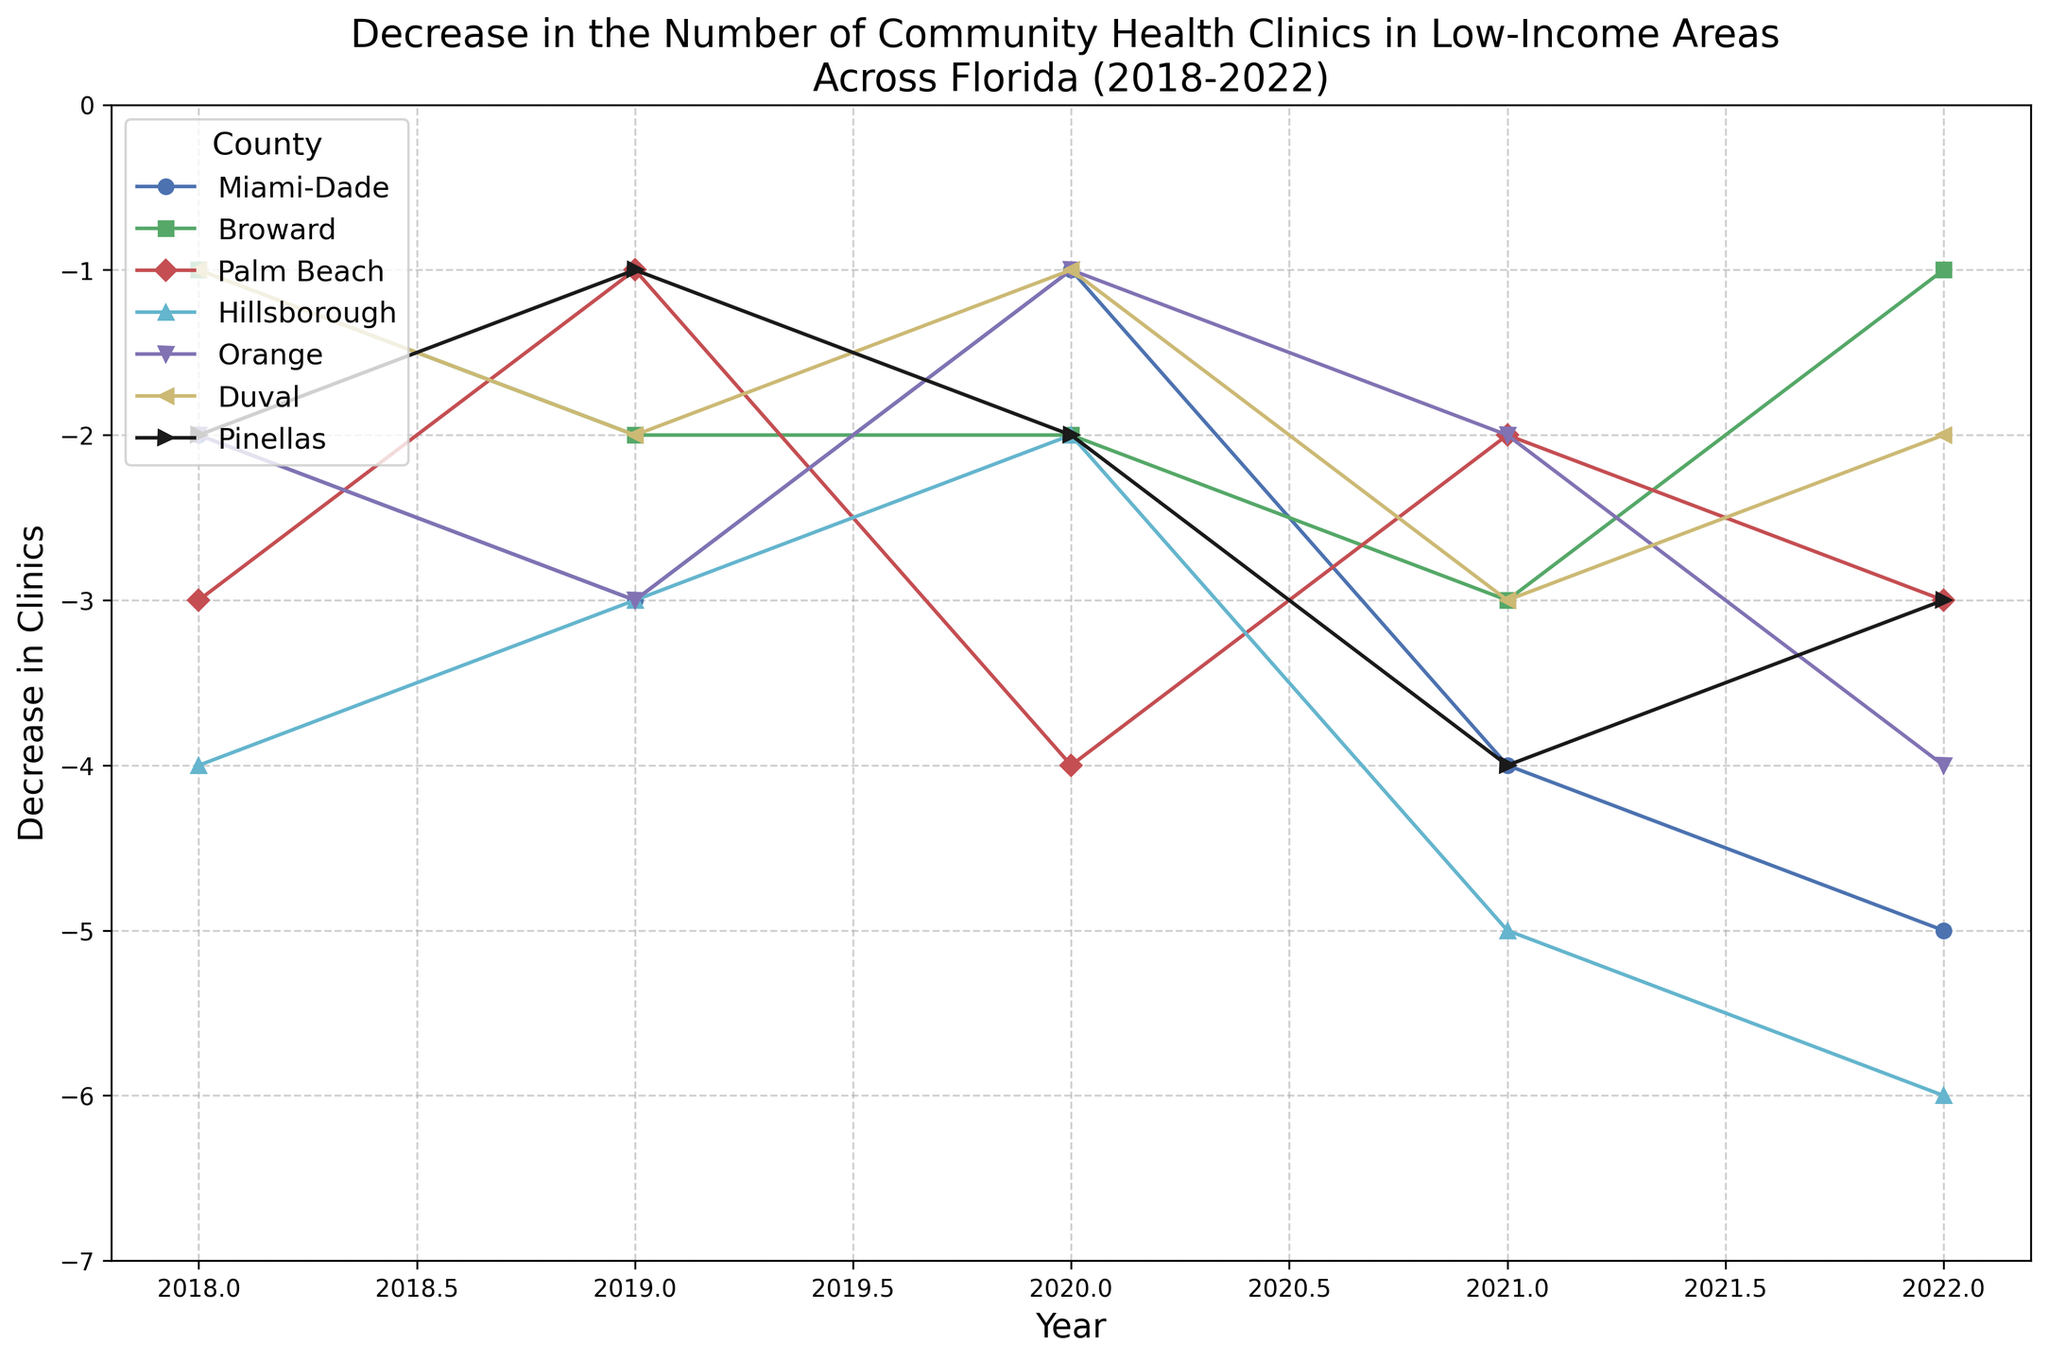What county experienced the most significant reduction in clinics in 2022? To identify the largest decrease in 2022, locate the data points corresponding to that year and note the value. The county with the value farthest from zero has the largest reduction. In 2022, Hillsborough had the most significant reduction with -6 clinics.
Answer: Hillsborough Which county had the smallest reduction in community health clinics over the 5 years? To find the smallest total reduction, sum the decrease in clinics for each county across all years. Compare these sums. Duval had reductions of (-1) + (-2) + (-1) + (-3) + (-2) = -9, which is the smallest.
Answer: Duval In which year did Pinellas county see its highest reduction in community health clinics? Look at the line representing Pinellas county and find the year corresponding to the lowest point on the graph. The highest reduction occurred in 2021 with -4 clinics.
Answer: 2021 Compare the decrease in clinics in 2019 between Miami-Dade and Orange counties. Which had a greater reduction? Compare the points for Miami-Dade and Orange in 2019. Miami-Dade had -3 and Orange had -3. Since the values are the same, there is no greater reduction.
Answer: Equal What is the average yearly decrease in community health clinics in Broward from 2018 to 2022? To calculate the average, sum the yearly decreases and divide by the number of years. For Broward: (-1) + (-2) + (-2) + (-3) + (-1) = -9, then -9 / 5 = -1.8
Answer: -1.8 Which year showed the least number of reductions across all counties? Examine each year and sum the decreases for all counties. Compare the totals for each year. The year with the smallest total reduction is 2020.
Answer: 2020 How did the reduction in community health clinics in Palm Beach in 2018 compare to 2022? Compare the values for Palm Beach in 2018 and 2022. In 2018, there was a reduction of -3 clinics, and in 2022, a reduction of -3 clinics. The values are the same.
Answer: Equal Which county's line is represented in blue? Observe the line colors linked to the legend. Miami-Dade's line is represented in blue.
Answer: Miami-Dade Calculate the total decrease in community health clinics across all counties in 2021. Sum the decreases for all counties in 2021. (-4) + (-3) + (-2) + (-5) + (-2) + (-3) + (-4) = -23
Answer: -23 